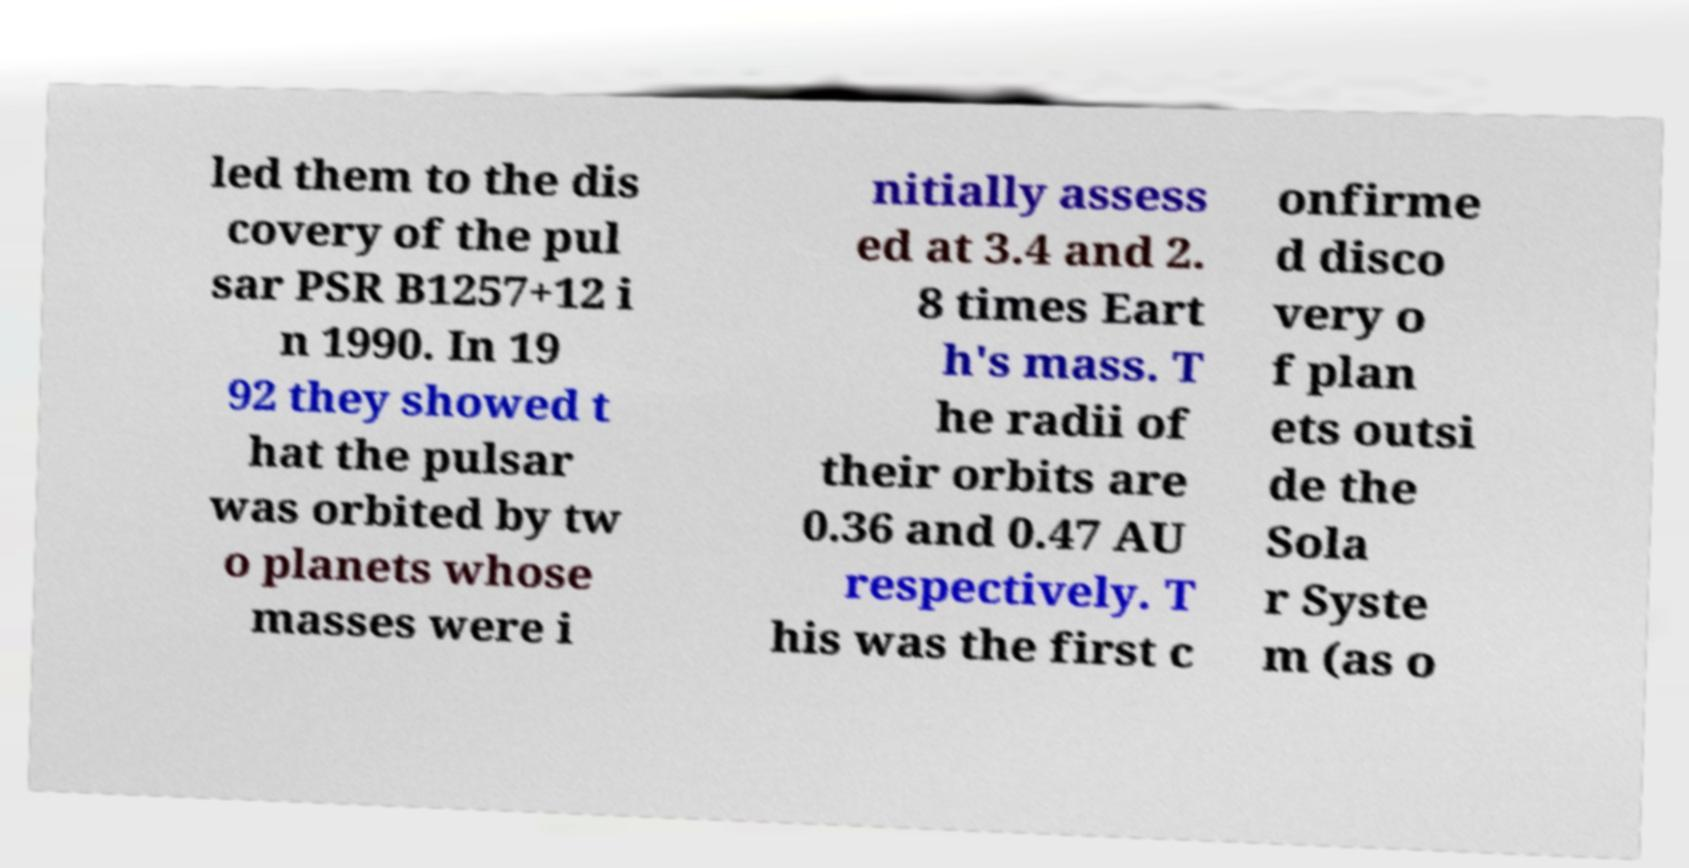For documentation purposes, I need the text within this image transcribed. Could you provide that? led them to the dis covery of the pul sar PSR B1257+12 i n 1990. In 19 92 they showed t hat the pulsar was orbited by tw o planets whose masses were i nitially assess ed at 3.4 and 2. 8 times Eart h's mass. T he radii of their orbits are 0.36 and 0.47 AU respectively. T his was the first c onfirme d disco very o f plan ets outsi de the Sola r Syste m (as o 